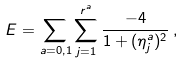Convert formula to latex. <formula><loc_0><loc_0><loc_500><loc_500>E = \sum _ { a = 0 , 1 } \sum _ { j = 1 } ^ { r ^ { a } } \frac { - 4 } { 1 + ( \eta _ { j } ^ { a } ) ^ { 2 } } \, ,</formula> 